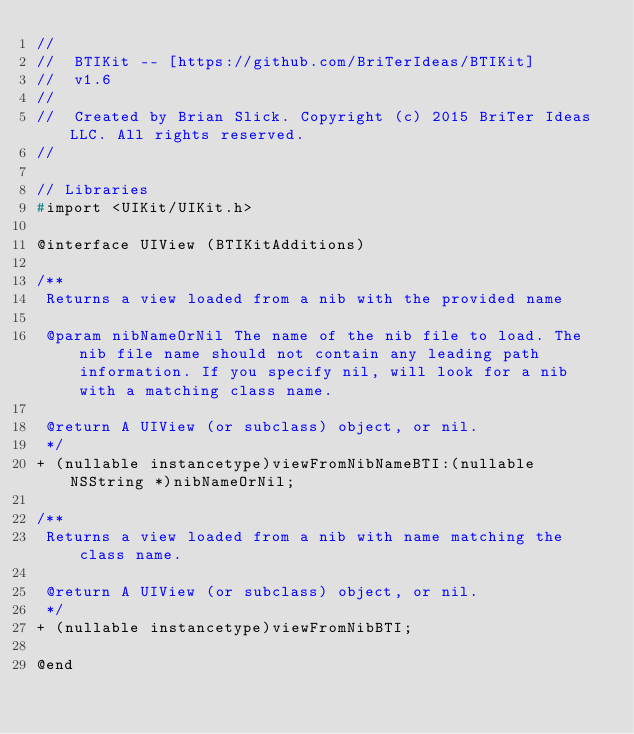<code> <loc_0><loc_0><loc_500><loc_500><_C_>//
//  BTIKit -- [https://github.com/BriTerIdeas/BTIKit]
//  v1.6
//
//  Created by Brian Slick. Copyright (c) 2015 BriTer Ideas LLC. All rights reserved.
//

// Libraries
#import <UIKit/UIKit.h>

@interface UIView (BTIKitAdditions)

/**
 Returns a view loaded from a nib with the provided name
 
 @param nibNameOrNil The name of the nib file to load. The nib file name should not contain any leading path information. If you specify nil, will look for a nib with a matching class name.
 
 @return A UIView (or subclass) object, or nil.
 */
+ (nullable instancetype)viewFromNibNameBTI:(nullable NSString *)nibNameOrNil;

/**
 Returns a view loaded from a nib with name matching the class name.
 
 @return A UIView (or subclass) object, or nil.
 */
+ (nullable instancetype)viewFromNibBTI;

@end
</code> 